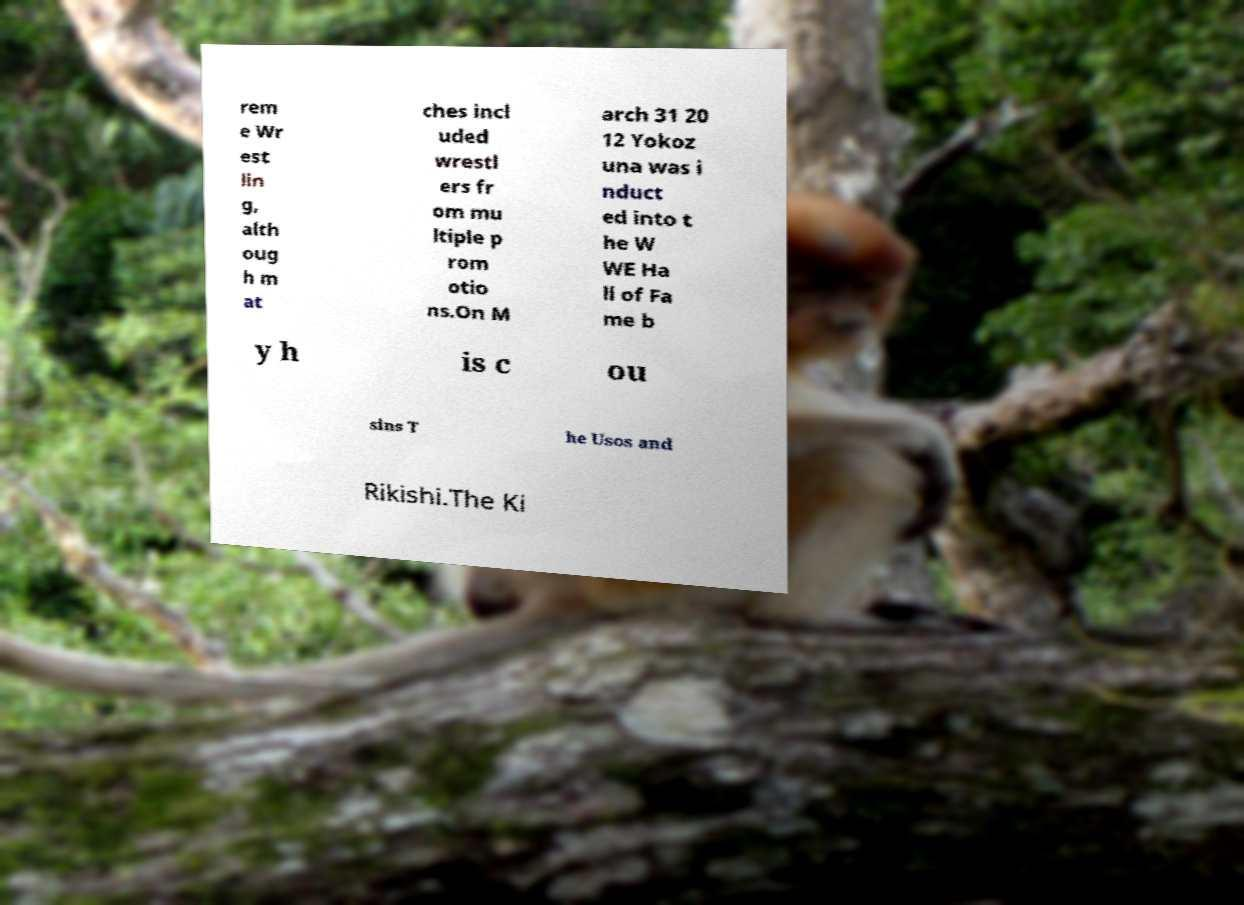Please read and relay the text visible in this image. What does it say? rem e Wr est lin g, alth oug h m at ches incl uded wrestl ers fr om mu ltiple p rom otio ns.On M arch 31 20 12 Yokoz una was i nduct ed into t he W WE Ha ll of Fa me b y h is c ou sins T he Usos and Rikishi.The Ki 